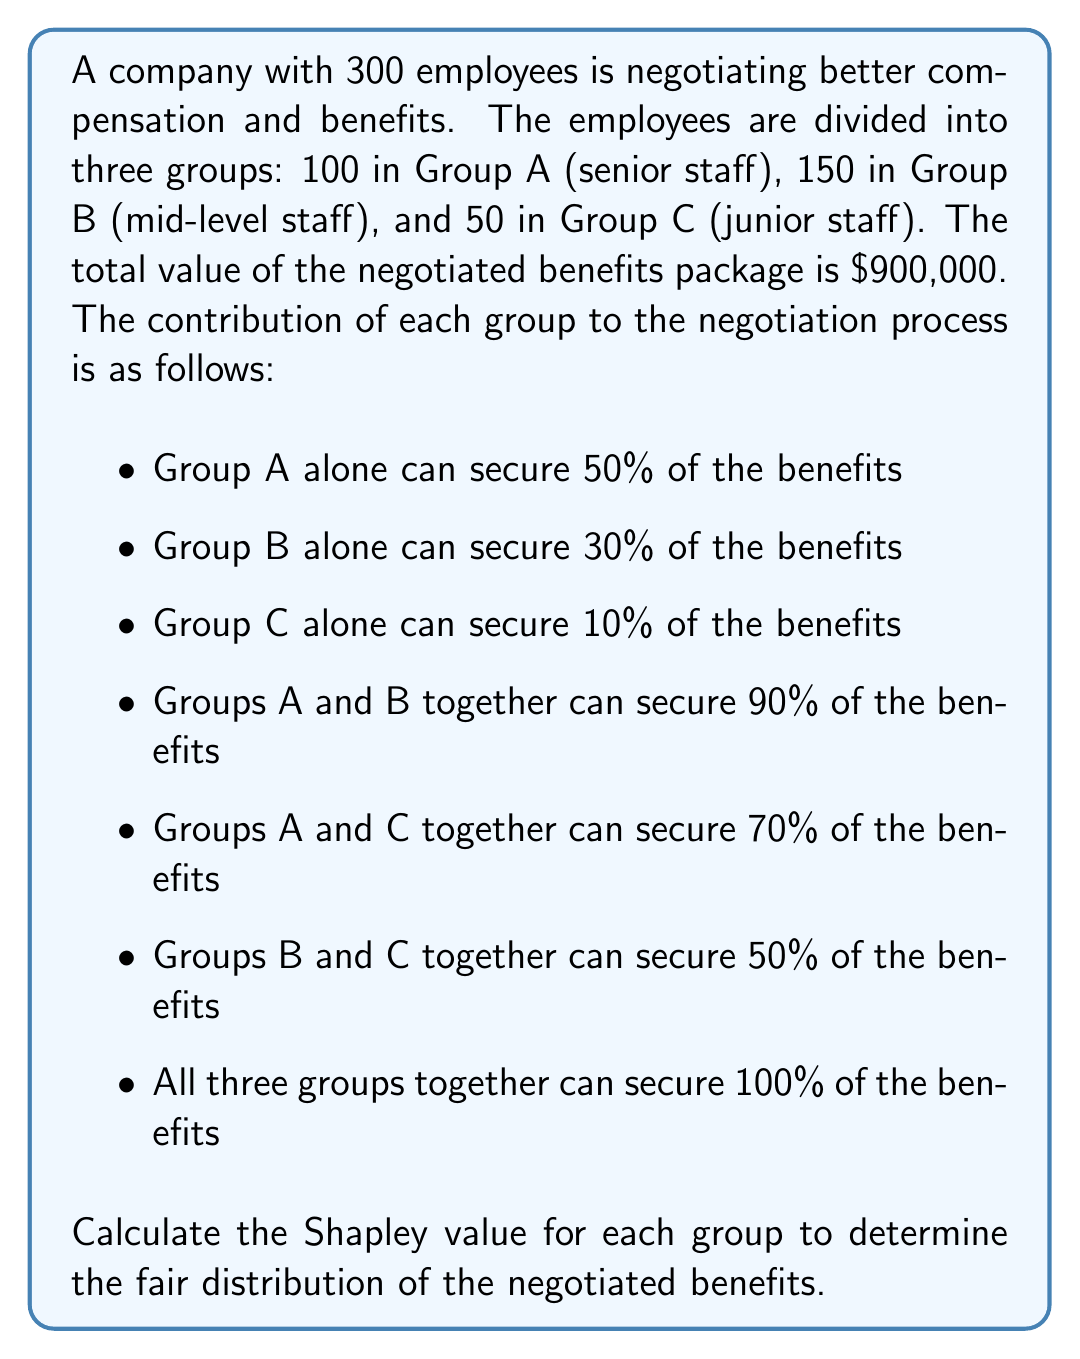Show me your answer to this math problem. To calculate the Shapley value, we need to consider all possible coalitions and determine each group's marginal contribution. The Shapley value formula is:

$$ \phi_i(v) = \sum_{S \subseteq N \setminus \{i\}} \frac{|S|!(n-|S|-1)!}{n!}[v(S \cup \{i\}) - v(S)] $$

Where:
- $\phi_i(v)$ is the Shapley value for player $i$
- $N$ is the set of all players
- $S$ is a subset of players not including $i$
- $n$ is the total number of players
- $v(S)$ is the value of coalition $S$

Step 1: List all possible coalitions and their values:
- $v(\emptyset) = 0$
- $v(A) = 450,000$
- $v(B) = 270,000$
- $v(C) = 90,000$
- $v(AB) = 810,000$
- $v(AC) = 630,000$
- $v(BC) = 450,000$
- $v(ABC) = 900,000$

Step 2: Calculate marginal contributions for each group in all possible orders:

Group A:
- A,B,C: 450,000
- A,C,B: 450,000
- B,A,C: 540,000
- B,C,A: 450,000
- C,A,B: 540,000
- C,B,A: 450,000

Group B:
- B,A,C: 270,000
- B,C,A: 360,000
- A,B,C: 360,000
- A,C,B: 270,000
- C,B,A: 360,000
- C,A,B: 270,000

Group C:
- C,A,B: 90,000
- C,B,A: 90,000
- A,C,B: 180,000
- A,B,C: 90,000
- B,C,A: 180,000
- B,A,C: 90,000

Step 3: Calculate the average of marginal contributions for each group:

Group A: $\frac{450,000 + 450,000 + 540,000 + 450,000 + 540,000 + 450,000}{6} = 480,000$

Group B: $\frac{270,000 + 360,000 + 360,000 + 270,000 + 360,000 + 270,000}{6} = 315,000$

Group C: $\frac{90,000 + 90,000 + 180,000 + 90,000 + 180,000 + 90,000}{6} = 105,000$

These averages represent the Shapley values for each group.
Answer: The Shapley values for fair distribution of the negotiated benefits are:

Group A (senior staff): $480,000
Group B (mid-level staff): $315,000
Group C (junior staff): $105,000 